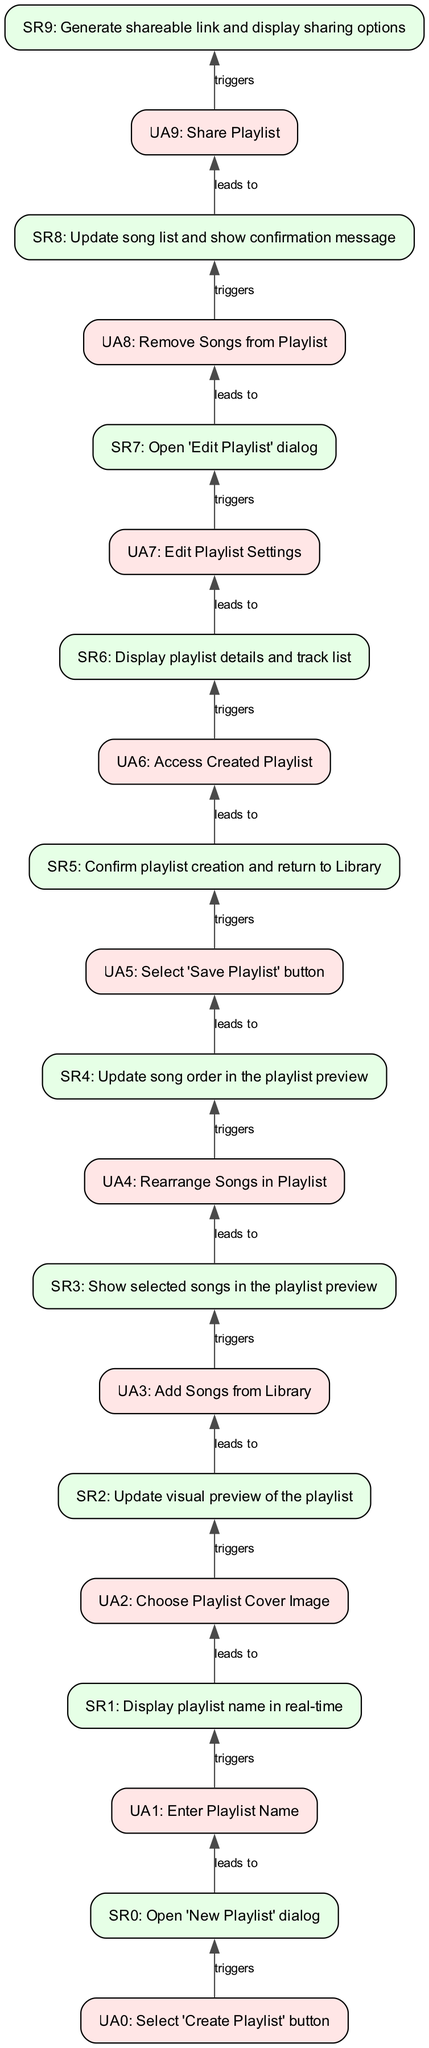What action leads to the system response "Open 'New Playlist' dialog"? The action that initiates this system response is the selection of the 'Create Playlist' button, as indicated by the first user action in the diagram.
Answer: Select 'Create Playlist' button How many user actions are depicted in the diagram? By counting the individual user actions listed in the diagram, there are a total of 10 user actions that represent different steps in the playlist creation and management workflow.
Answer: 10 What is the system response after "Add Songs from Library"? Following the "Add Songs from Library" action, the resulting system response is to show the selected songs in the playlist preview, as indicated in the diagram's flow.
Answer: Show selected songs in the playlist preview What is the last user action shown in the diagram? The last user action listed in the diagram is "Share Playlist," which indicates that this is the final action that a user can take regarding their playlists within the workflow.
Answer: Share Playlist Which user action directly follows the "Enter Playlist Name"? The user action that follows "Enter Playlist Name" is "Choose Playlist Cover Image," based on the sequential flow depicted in the diagram.
Answer: Choose Playlist Cover Image What happens after "Rearrange Songs in Playlist"? After the action "Rearrange Songs in Playlist," the system response is to update the song order in the playlist preview, which is the appropriate next step as specified in the diagram.
Answer: Update song order in the playlist preview Which two actions lead to the system response "Display playlist details and track list"? The actions that lead to "Display playlist details and track list" are "Access Created Playlist" which directly triggers this response, indicating what the user sees when accessing the created playlist.
Answer: Access Created Playlist, Edit Playlist Settings How does a user confirm the creation of a playlist? A user confirms the creation of a playlist by selecting the 'Save Playlist' button, which triggers a system response that confirms the playlist creation and returns to the Library interface.
Answer: Select 'Save Playlist' button 